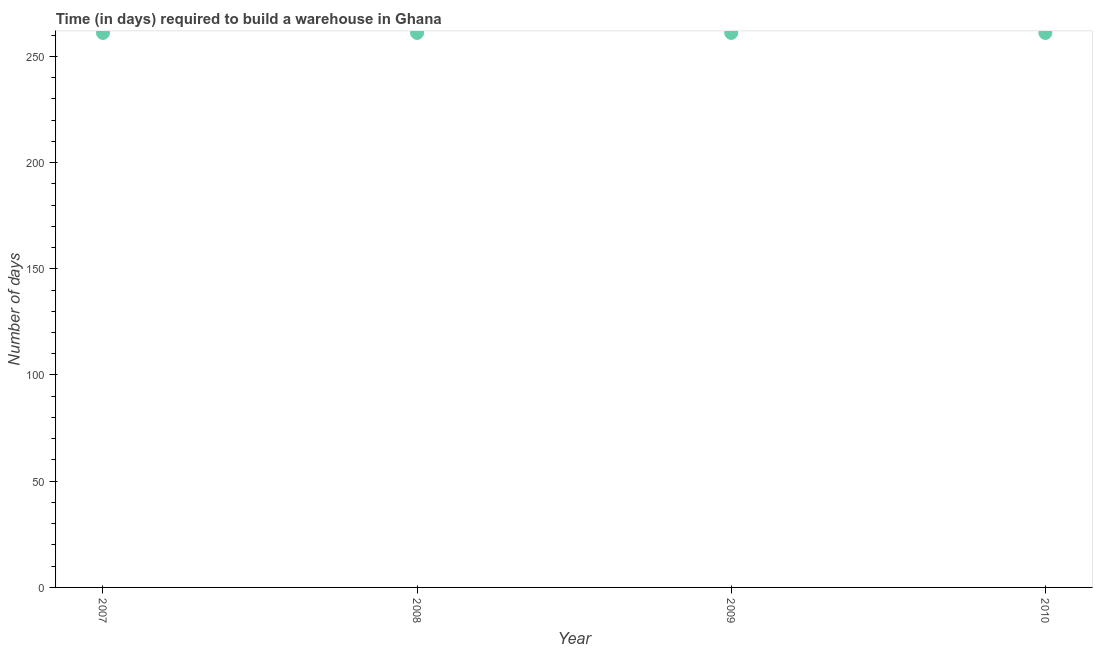What is the time required to build a warehouse in 2007?
Your response must be concise. 261. Across all years, what is the maximum time required to build a warehouse?
Offer a very short reply. 261. Across all years, what is the minimum time required to build a warehouse?
Offer a terse response. 261. What is the sum of the time required to build a warehouse?
Give a very brief answer. 1044. What is the difference between the time required to build a warehouse in 2007 and 2010?
Your answer should be compact. 0. What is the average time required to build a warehouse per year?
Provide a short and direct response. 261. What is the median time required to build a warehouse?
Your answer should be very brief. 261. In how many years, is the time required to build a warehouse greater than 150 days?
Offer a terse response. 4. Do a majority of the years between 2010 and 2008 (inclusive) have time required to build a warehouse greater than 20 days?
Your response must be concise. No. Is the sum of the time required to build a warehouse in 2007 and 2008 greater than the maximum time required to build a warehouse across all years?
Your response must be concise. Yes. What is the difference between the highest and the lowest time required to build a warehouse?
Your response must be concise. 0. Does the time required to build a warehouse monotonically increase over the years?
Your answer should be very brief. No. What is the difference between two consecutive major ticks on the Y-axis?
Offer a very short reply. 50. Does the graph contain grids?
Ensure brevity in your answer.  No. What is the title of the graph?
Offer a very short reply. Time (in days) required to build a warehouse in Ghana. What is the label or title of the Y-axis?
Make the answer very short. Number of days. What is the Number of days in 2007?
Your answer should be compact. 261. What is the Number of days in 2008?
Offer a very short reply. 261. What is the Number of days in 2009?
Provide a short and direct response. 261. What is the Number of days in 2010?
Ensure brevity in your answer.  261. What is the difference between the Number of days in 2007 and 2009?
Make the answer very short. 0. What is the difference between the Number of days in 2008 and 2009?
Make the answer very short. 0. What is the difference between the Number of days in 2008 and 2010?
Offer a terse response. 0. What is the ratio of the Number of days in 2007 to that in 2008?
Keep it short and to the point. 1. What is the ratio of the Number of days in 2007 to that in 2009?
Offer a terse response. 1. What is the ratio of the Number of days in 2007 to that in 2010?
Make the answer very short. 1. 